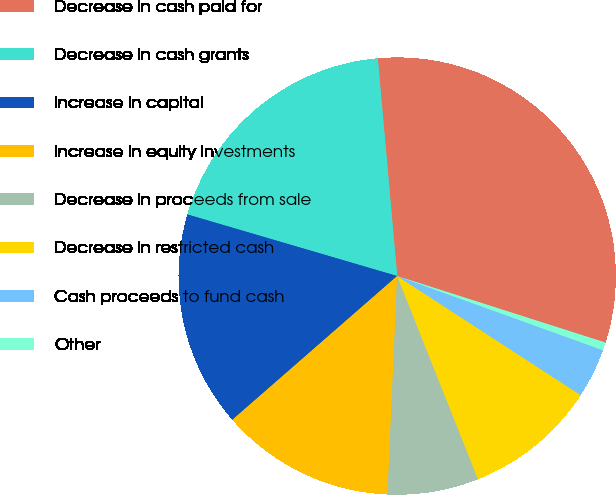<chart> <loc_0><loc_0><loc_500><loc_500><pie_chart><fcel>Decrease in cash paid for<fcel>Decrease in cash grants<fcel>Increase in capital<fcel>Increase in equity investments<fcel>Decrease in proceeds from sale<fcel>Decrease in restricted cash<fcel>Cash proceeds to fund cash<fcel>Other<nl><fcel>31.34%<fcel>19.04%<fcel>15.96%<fcel>12.88%<fcel>6.73%<fcel>9.81%<fcel>3.66%<fcel>0.58%<nl></chart> 